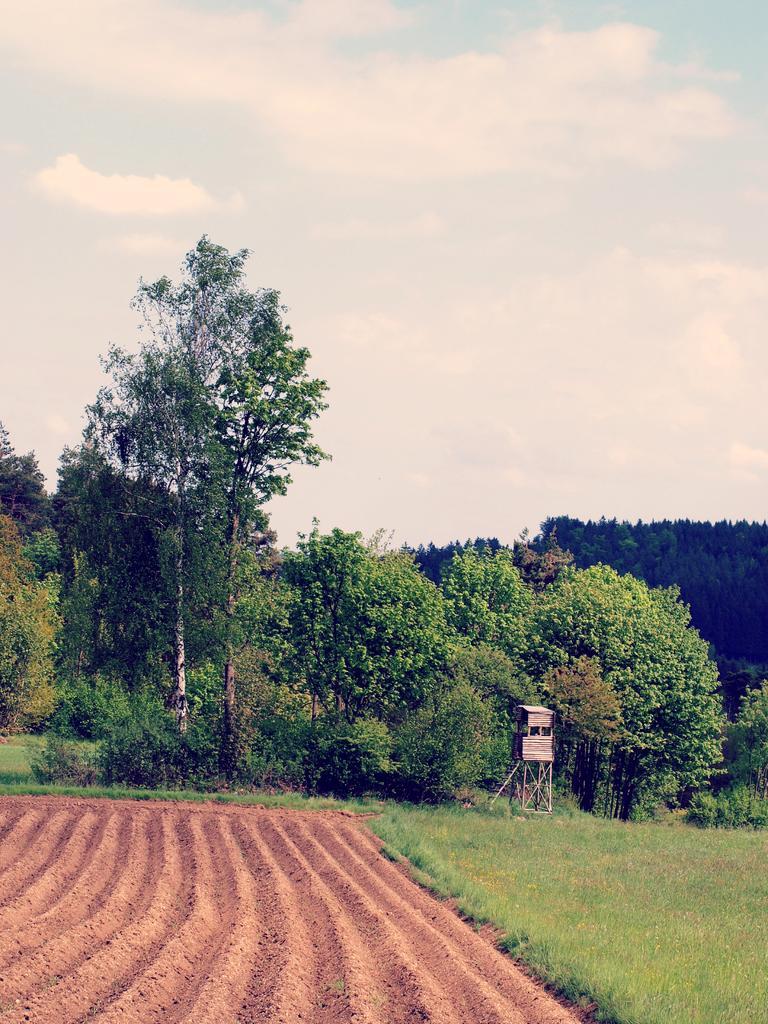How would you summarize this image in a sentence or two? In the image we can see there is a grass on the right side and sand on the left side and some trees. On the top there is a sky. 